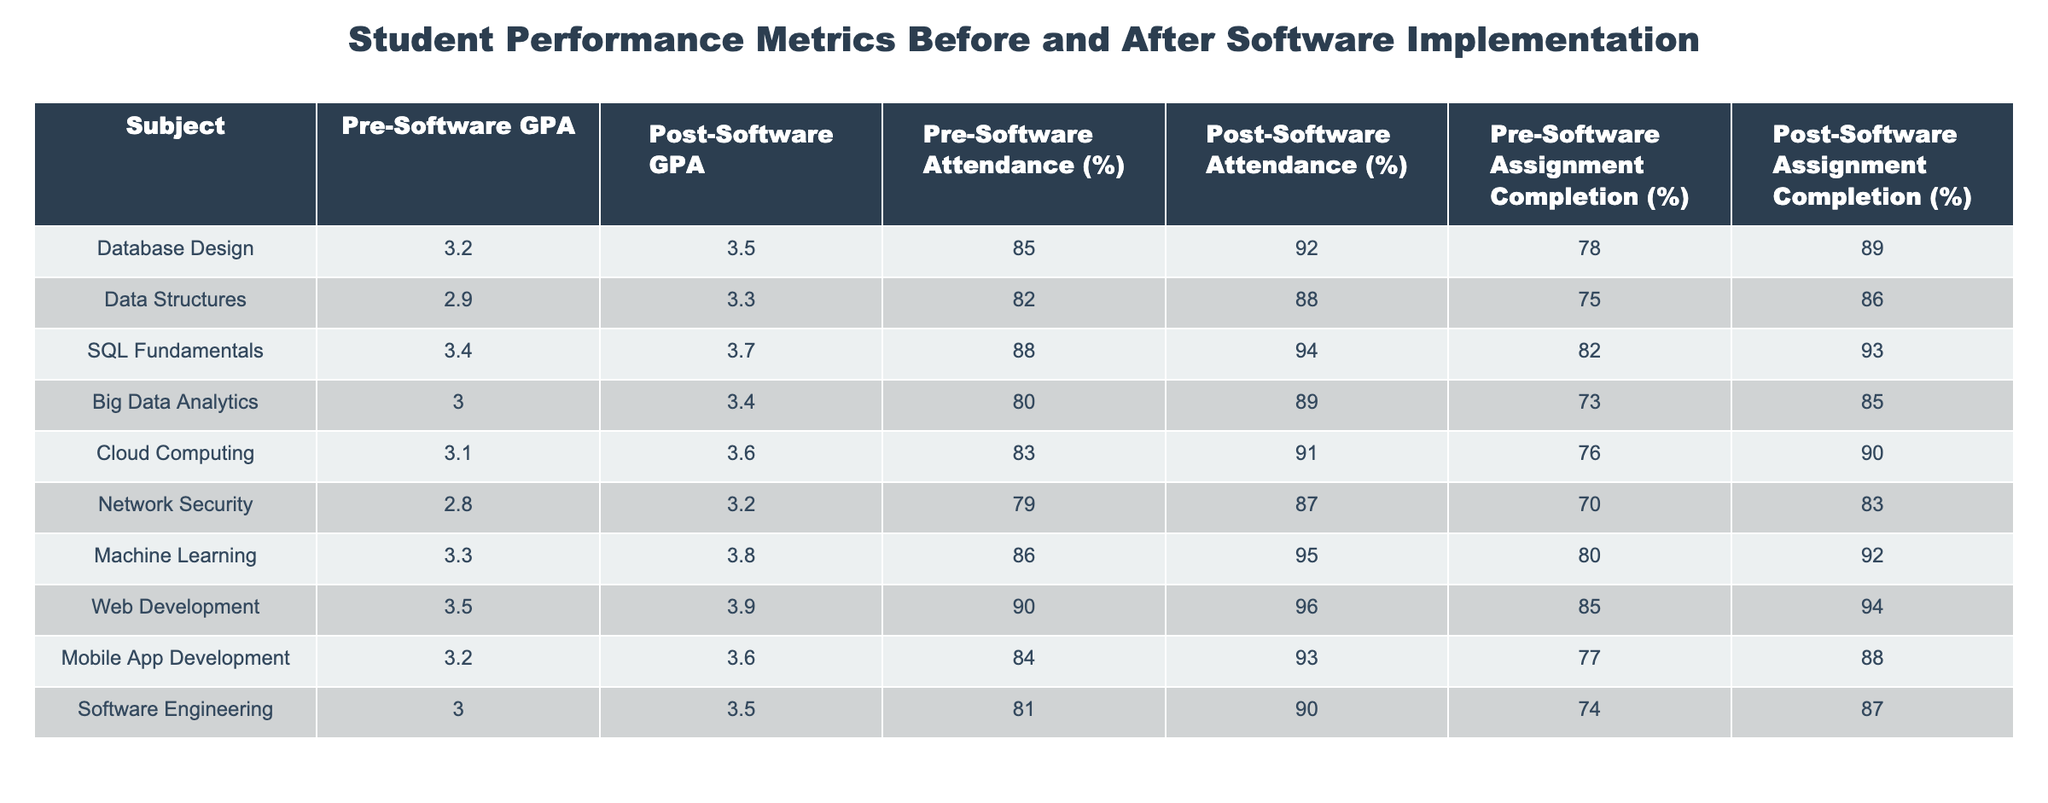What is the Post-Software GPA for Cloud Computing? According to the table, the Post-Software GPA for Cloud Computing is listed directly under that subject in the Post-Software GPA column, which shows a value of 3.6.
Answer: 3.6 What is the difference in Pre-Software Attendance percentage between Database Design and Network Security? For Database Design, the Pre-Software Attendance is 85%, and for Network Security, it is 79%. To find the difference, we subtract: 85 - 79 = 6.
Answer: 6 Did the Post-Software Assignment Completion percentage for Machine Learning exceed 92%? The table shows the Post-Software Assignment Completion percentage for Machine Learning is 92%. Since 92% is not greater than 92%, the answer is no.
Answer: No What is the average Pre-Software GPA for all subjects listed in the table? To find the average Pre-Software GPA, we sum all the values: 3.2 + 2.9 + 3.4 + 3.0 + 3.1 + 2.8 + 3.3 + 3.5 + 3.2 + 3.0 = 31.4. There are 10 subjects, thus the average is 31.4 / 10 = 3.14.
Answer: 3.14 Which subject had the highest increase in GPA after implementing the software? By examining the differences between Pre-Software and Post-Software GPAs for each subject, we find: 
- Database Design: 3.5 - 3.2 = 0.3 
- Data Structures: 3.3 - 2.9 = 0.4 
- SQL Fundamentals: 3.7 - 3.4 = 0.3 
- Big Data Analytics: 3.4 - 3.0 = 0.4 
- Cloud Computing: 3.6 - 3.1 = 0.5 
- Network Security: 3.2 - 2.8 = 0.4 
- Machine Learning: 3.8 - 3.3 = 0.5 
- Web Development: 3.9 - 3.5 = 0.4 
- Mobile App Development: 3.6 - 3.2 = 0.4 
- Software Engineering: 3.5 - 3.0 = 0.5 
The subjects Cloud Computing, Machine Learning, and Software Engineering each had the highest increase of 0.5.
Answer: Cloud Computing, Machine Learning, Software Engineering 